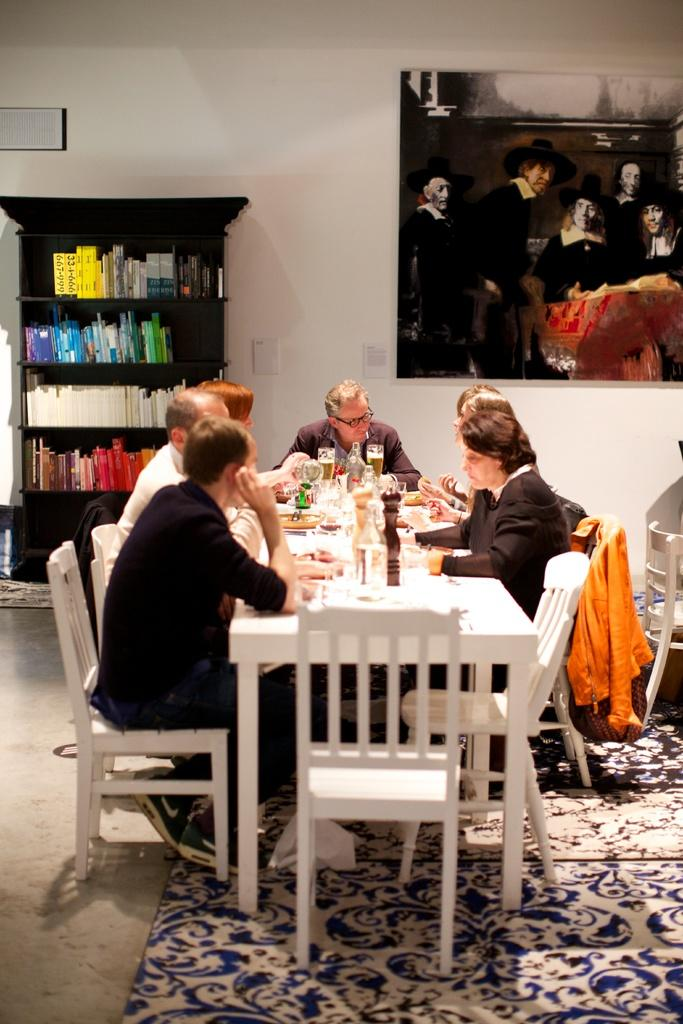What are the people in the image doing? There are people sitting in the image. What objects are on the table in the image? There are glasses and a bottle on a table in the image. What can be seen in the background of the image? There are books in a rack in the background of the image. What is attached to the wall in the image? There is a frame attached to a wall in the image. What type of thumb is being used to perform magic in the image? There is no thumb or magic present in the image; it features people sitting, glasses, a bottle, books, and a frame. 